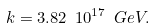<formula> <loc_0><loc_0><loc_500><loc_500>k = 3 . 8 2 \ 1 0 ^ { 1 7 } \ G e V .</formula> 